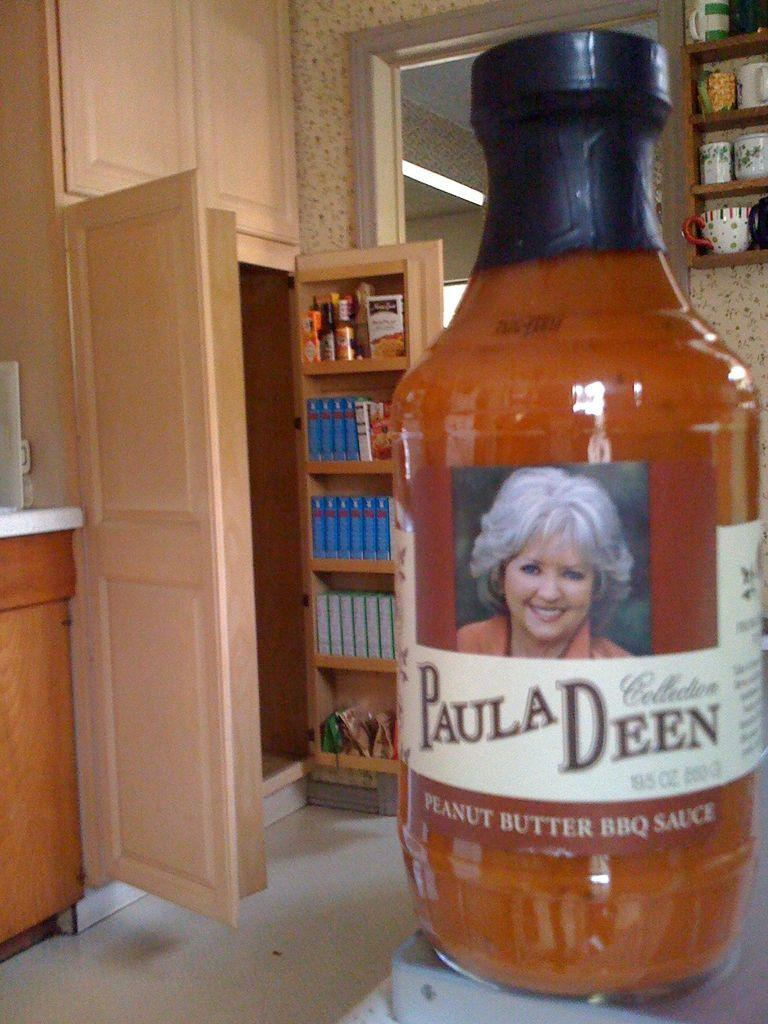<image>
Create a compact narrative representing the image presented. A bottle of Paula Deen Peanut Butter BBQ Sauce sits on the counter in a kitchen. 